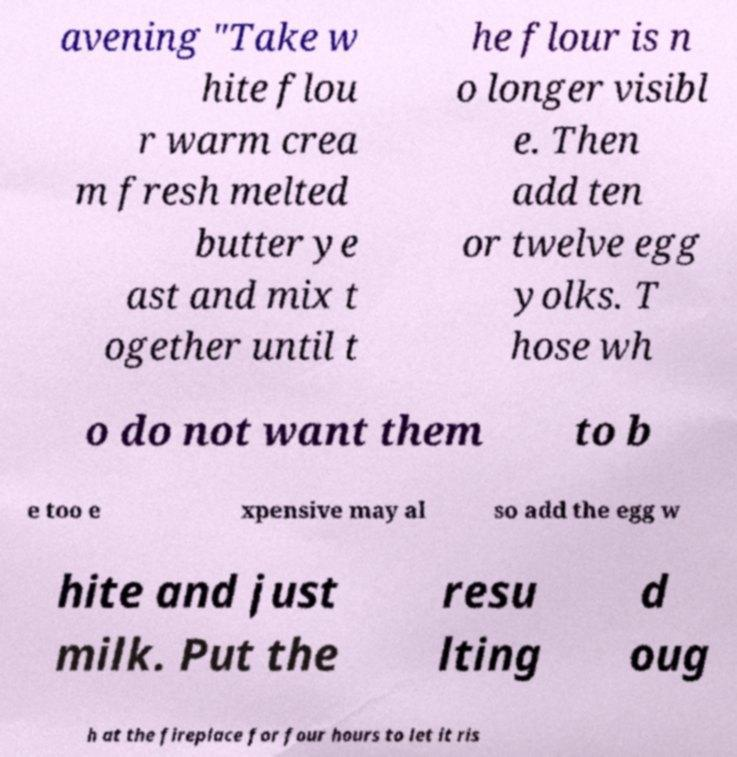Can you accurately transcribe the text from the provided image for me? avening "Take w hite flou r warm crea m fresh melted butter ye ast and mix t ogether until t he flour is n o longer visibl e. Then add ten or twelve egg yolks. T hose wh o do not want them to b e too e xpensive may al so add the egg w hite and just milk. Put the resu lting d oug h at the fireplace for four hours to let it ris 